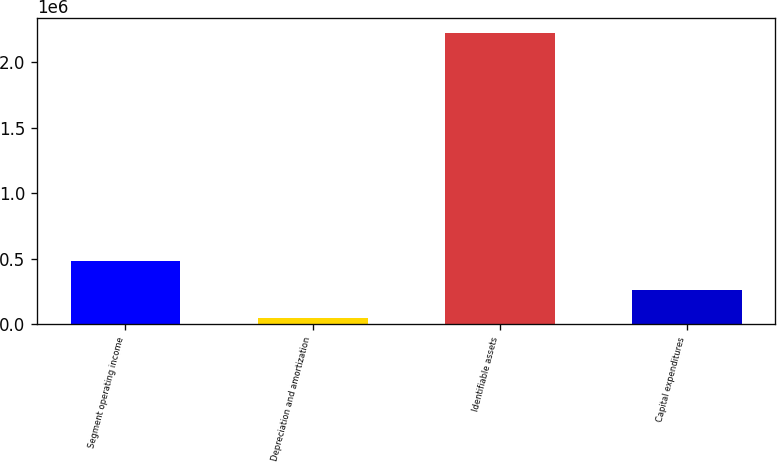<chart> <loc_0><loc_0><loc_500><loc_500><bar_chart><fcel>Segment operating income<fcel>Depreciation and amortization<fcel>Identifiable assets<fcel>Capital expenditures<nl><fcel>483164<fcel>48007<fcel>2.22379e+06<fcel>265585<nl></chart> 